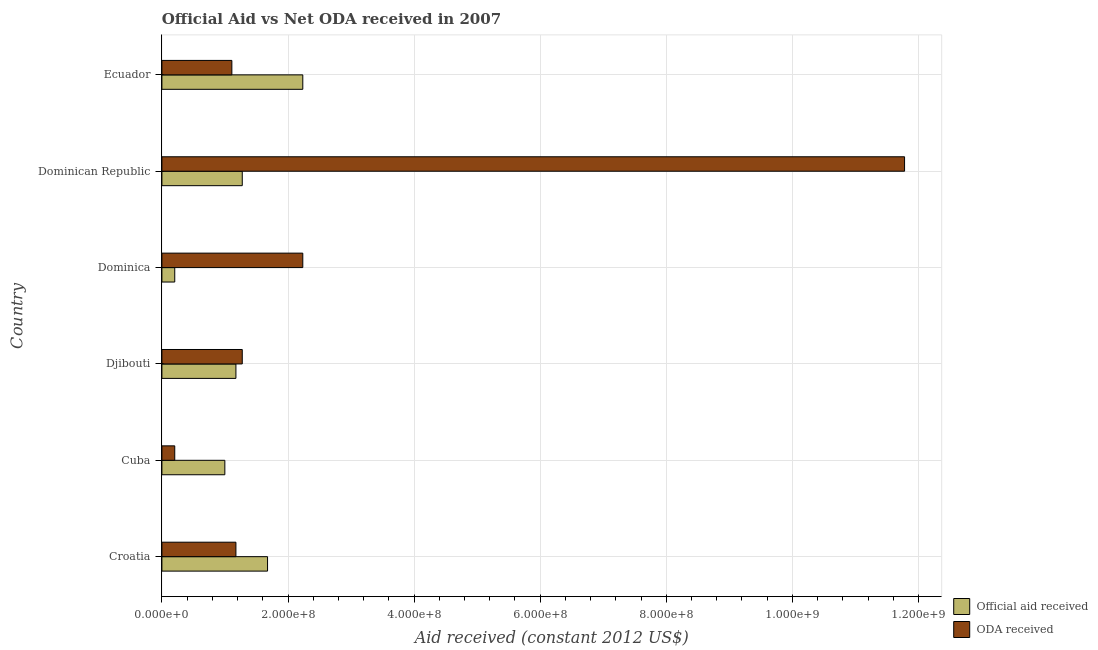What is the label of the 3rd group of bars from the top?
Offer a very short reply. Dominica. In how many cases, is the number of bars for a given country not equal to the number of legend labels?
Make the answer very short. 0. What is the oda received in Ecuador?
Your answer should be very brief. 1.11e+08. Across all countries, what is the maximum official aid received?
Make the answer very short. 2.23e+08. Across all countries, what is the minimum official aid received?
Ensure brevity in your answer.  2.04e+07. In which country was the oda received maximum?
Give a very brief answer. Dominican Republic. In which country was the oda received minimum?
Offer a terse response. Cuba. What is the total oda received in the graph?
Make the answer very short. 1.78e+09. What is the difference between the official aid received in Croatia and that in Ecuador?
Provide a short and direct response. -5.59e+07. What is the difference between the oda received in Croatia and the official aid received in Dominica?
Your answer should be very brief. 9.70e+07. What is the average official aid received per country?
Offer a terse response. 1.26e+08. What is the difference between the oda received and official aid received in Dominica?
Your response must be concise. 2.03e+08. What is the ratio of the official aid received in Djibouti to that in Ecuador?
Offer a very short reply. 0.53. What is the difference between the highest and the second highest oda received?
Your answer should be very brief. 9.54e+08. What is the difference between the highest and the lowest oda received?
Your response must be concise. 1.16e+09. What does the 2nd bar from the top in Djibouti represents?
Ensure brevity in your answer.  Official aid received. What does the 2nd bar from the bottom in Djibouti represents?
Offer a very short reply. ODA received. Are all the bars in the graph horizontal?
Give a very brief answer. Yes. What is the difference between two consecutive major ticks on the X-axis?
Your answer should be very brief. 2.00e+08. Does the graph contain grids?
Give a very brief answer. Yes. Where does the legend appear in the graph?
Ensure brevity in your answer.  Bottom right. What is the title of the graph?
Your response must be concise. Official Aid vs Net ODA received in 2007 . What is the label or title of the X-axis?
Your response must be concise. Aid received (constant 2012 US$). What is the Aid received (constant 2012 US$) in Official aid received in Croatia?
Offer a terse response. 1.68e+08. What is the Aid received (constant 2012 US$) in ODA received in Croatia?
Make the answer very short. 1.17e+08. What is the Aid received (constant 2012 US$) of Official aid received in Cuba?
Keep it short and to the point. 9.98e+07. What is the Aid received (constant 2012 US$) of ODA received in Cuba?
Provide a short and direct response. 2.04e+07. What is the Aid received (constant 2012 US$) in Official aid received in Djibouti?
Make the answer very short. 1.17e+08. What is the Aid received (constant 2012 US$) in ODA received in Djibouti?
Offer a very short reply. 1.27e+08. What is the Aid received (constant 2012 US$) in Official aid received in Dominica?
Give a very brief answer. 2.04e+07. What is the Aid received (constant 2012 US$) in ODA received in Dominica?
Keep it short and to the point. 2.23e+08. What is the Aid received (constant 2012 US$) in Official aid received in Dominican Republic?
Ensure brevity in your answer.  1.27e+08. What is the Aid received (constant 2012 US$) of ODA received in Dominican Republic?
Make the answer very short. 1.18e+09. What is the Aid received (constant 2012 US$) in Official aid received in Ecuador?
Your answer should be very brief. 2.23e+08. What is the Aid received (constant 2012 US$) in ODA received in Ecuador?
Provide a short and direct response. 1.11e+08. Across all countries, what is the maximum Aid received (constant 2012 US$) in Official aid received?
Give a very brief answer. 2.23e+08. Across all countries, what is the maximum Aid received (constant 2012 US$) of ODA received?
Give a very brief answer. 1.18e+09. Across all countries, what is the minimum Aid received (constant 2012 US$) in Official aid received?
Your answer should be compact. 2.04e+07. Across all countries, what is the minimum Aid received (constant 2012 US$) in ODA received?
Offer a terse response. 2.04e+07. What is the total Aid received (constant 2012 US$) of Official aid received in the graph?
Make the answer very short. 7.56e+08. What is the total Aid received (constant 2012 US$) in ODA received in the graph?
Your answer should be very brief. 1.78e+09. What is the difference between the Aid received (constant 2012 US$) of Official aid received in Croatia and that in Cuba?
Your response must be concise. 6.77e+07. What is the difference between the Aid received (constant 2012 US$) in ODA received in Croatia and that in Cuba?
Your response must be concise. 9.70e+07. What is the difference between the Aid received (constant 2012 US$) of Official aid received in Croatia and that in Djibouti?
Provide a short and direct response. 5.02e+07. What is the difference between the Aid received (constant 2012 US$) in ODA received in Croatia and that in Djibouti?
Your response must be concise. -1.01e+07. What is the difference between the Aid received (constant 2012 US$) of Official aid received in Croatia and that in Dominica?
Your answer should be very brief. 1.47e+08. What is the difference between the Aid received (constant 2012 US$) of ODA received in Croatia and that in Dominica?
Make the answer very short. -1.06e+08. What is the difference between the Aid received (constant 2012 US$) of Official aid received in Croatia and that in Dominican Republic?
Keep it short and to the point. 4.01e+07. What is the difference between the Aid received (constant 2012 US$) in ODA received in Croatia and that in Dominican Republic?
Your answer should be compact. -1.06e+09. What is the difference between the Aid received (constant 2012 US$) of Official aid received in Croatia and that in Ecuador?
Make the answer very short. -5.59e+07. What is the difference between the Aid received (constant 2012 US$) of ODA received in Croatia and that in Ecuador?
Keep it short and to the point. 6.43e+06. What is the difference between the Aid received (constant 2012 US$) in Official aid received in Cuba and that in Djibouti?
Keep it short and to the point. -1.76e+07. What is the difference between the Aid received (constant 2012 US$) in ODA received in Cuba and that in Djibouti?
Offer a terse response. -1.07e+08. What is the difference between the Aid received (constant 2012 US$) in Official aid received in Cuba and that in Dominica?
Provide a short and direct response. 7.94e+07. What is the difference between the Aid received (constant 2012 US$) of ODA received in Cuba and that in Dominica?
Your answer should be very brief. -2.03e+08. What is the difference between the Aid received (constant 2012 US$) in Official aid received in Cuba and that in Dominican Republic?
Provide a short and direct response. -2.76e+07. What is the difference between the Aid received (constant 2012 US$) of ODA received in Cuba and that in Dominican Republic?
Provide a short and direct response. -1.16e+09. What is the difference between the Aid received (constant 2012 US$) in Official aid received in Cuba and that in Ecuador?
Your answer should be compact. -1.24e+08. What is the difference between the Aid received (constant 2012 US$) of ODA received in Cuba and that in Ecuador?
Offer a very short reply. -9.06e+07. What is the difference between the Aid received (constant 2012 US$) of Official aid received in Djibouti and that in Dominica?
Offer a terse response. 9.70e+07. What is the difference between the Aid received (constant 2012 US$) in ODA received in Djibouti and that in Dominica?
Offer a terse response. -9.60e+07. What is the difference between the Aid received (constant 2012 US$) in Official aid received in Djibouti and that in Dominican Republic?
Your response must be concise. -1.01e+07. What is the difference between the Aid received (constant 2012 US$) in ODA received in Djibouti and that in Dominican Republic?
Your answer should be compact. -1.05e+09. What is the difference between the Aid received (constant 2012 US$) in Official aid received in Djibouti and that in Ecuador?
Offer a very short reply. -1.06e+08. What is the difference between the Aid received (constant 2012 US$) in ODA received in Djibouti and that in Ecuador?
Your response must be concise. 1.65e+07. What is the difference between the Aid received (constant 2012 US$) in Official aid received in Dominica and that in Dominican Republic?
Offer a very short reply. -1.07e+08. What is the difference between the Aid received (constant 2012 US$) in ODA received in Dominica and that in Dominican Republic?
Provide a succinct answer. -9.54e+08. What is the difference between the Aid received (constant 2012 US$) of Official aid received in Dominica and that in Ecuador?
Your answer should be compact. -2.03e+08. What is the difference between the Aid received (constant 2012 US$) in ODA received in Dominica and that in Ecuador?
Keep it short and to the point. 1.12e+08. What is the difference between the Aid received (constant 2012 US$) of Official aid received in Dominican Republic and that in Ecuador?
Make the answer very short. -9.60e+07. What is the difference between the Aid received (constant 2012 US$) of ODA received in Dominican Republic and that in Ecuador?
Offer a terse response. 1.07e+09. What is the difference between the Aid received (constant 2012 US$) in Official aid received in Croatia and the Aid received (constant 2012 US$) in ODA received in Cuba?
Your answer should be compact. 1.47e+08. What is the difference between the Aid received (constant 2012 US$) of Official aid received in Croatia and the Aid received (constant 2012 US$) of ODA received in Djibouti?
Your answer should be compact. 4.01e+07. What is the difference between the Aid received (constant 2012 US$) of Official aid received in Croatia and the Aid received (constant 2012 US$) of ODA received in Dominica?
Give a very brief answer. -5.59e+07. What is the difference between the Aid received (constant 2012 US$) in Official aid received in Croatia and the Aid received (constant 2012 US$) in ODA received in Dominican Republic?
Provide a succinct answer. -1.01e+09. What is the difference between the Aid received (constant 2012 US$) of Official aid received in Croatia and the Aid received (constant 2012 US$) of ODA received in Ecuador?
Make the answer very short. 5.66e+07. What is the difference between the Aid received (constant 2012 US$) in Official aid received in Cuba and the Aid received (constant 2012 US$) in ODA received in Djibouti?
Provide a succinct answer. -2.76e+07. What is the difference between the Aid received (constant 2012 US$) in Official aid received in Cuba and the Aid received (constant 2012 US$) in ODA received in Dominica?
Provide a succinct answer. -1.24e+08. What is the difference between the Aid received (constant 2012 US$) of Official aid received in Cuba and the Aid received (constant 2012 US$) of ODA received in Dominican Republic?
Your answer should be compact. -1.08e+09. What is the difference between the Aid received (constant 2012 US$) in Official aid received in Cuba and the Aid received (constant 2012 US$) in ODA received in Ecuador?
Your answer should be compact. -1.11e+07. What is the difference between the Aid received (constant 2012 US$) in Official aid received in Djibouti and the Aid received (constant 2012 US$) in ODA received in Dominica?
Ensure brevity in your answer.  -1.06e+08. What is the difference between the Aid received (constant 2012 US$) of Official aid received in Djibouti and the Aid received (constant 2012 US$) of ODA received in Dominican Republic?
Offer a very short reply. -1.06e+09. What is the difference between the Aid received (constant 2012 US$) in Official aid received in Djibouti and the Aid received (constant 2012 US$) in ODA received in Ecuador?
Make the answer very short. 6.43e+06. What is the difference between the Aid received (constant 2012 US$) in Official aid received in Dominica and the Aid received (constant 2012 US$) in ODA received in Dominican Republic?
Give a very brief answer. -1.16e+09. What is the difference between the Aid received (constant 2012 US$) in Official aid received in Dominica and the Aid received (constant 2012 US$) in ODA received in Ecuador?
Make the answer very short. -9.06e+07. What is the difference between the Aid received (constant 2012 US$) of Official aid received in Dominican Republic and the Aid received (constant 2012 US$) of ODA received in Ecuador?
Your answer should be very brief. 1.65e+07. What is the average Aid received (constant 2012 US$) of Official aid received per country?
Provide a succinct answer. 1.26e+08. What is the average Aid received (constant 2012 US$) of ODA received per country?
Your answer should be compact. 2.96e+08. What is the difference between the Aid received (constant 2012 US$) of Official aid received and Aid received (constant 2012 US$) of ODA received in Croatia?
Your answer should be very brief. 5.02e+07. What is the difference between the Aid received (constant 2012 US$) of Official aid received and Aid received (constant 2012 US$) of ODA received in Cuba?
Your answer should be compact. 7.94e+07. What is the difference between the Aid received (constant 2012 US$) in Official aid received and Aid received (constant 2012 US$) in ODA received in Djibouti?
Provide a succinct answer. -1.01e+07. What is the difference between the Aid received (constant 2012 US$) in Official aid received and Aid received (constant 2012 US$) in ODA received in Dominica?
Ensure brevity in your answer.  -2.03e+08. What is the difference between the Aid received (constant 2012 US$) in Official aid received and Aid received (constant 2012 US$) in ODA received in Dominican Republic?
Your response must be concise. -1.05e+09. What is the difference between the Aid received (constant 2012 US$) in Official aid received and Aid received (constant 2012 US$) in ODA received in Ecuador?
Your answer should be very brief. 1.12e+08. What is the ratio of the Aid received (constant 2012 US$) of Official aid received in Croatia to that in Cuba?
Provide a succinct answer. 1.68. What is the ratio of the Aid received (constant 2012 US$) in ODA received in Croatia to that in Cuba?
Ensure brevity in your answer.  5.76. What is the ratio of the Aid received (constant 2012 US$) of Official aid received in Croatia to that in Djibouti?
Provide a succinct answer. 1.43. What is the ratio of the Aid received (constant 2012 US$) in ODA received in Croatia to that in Djibouti?
Offer a very short reply. 0.92. What is the ratio of the Aid received (constant 2012 US$) in Official aid received in Croatia to that in Dominica?
Your answer should be compact. 8.22. What is the ratio of the Aid received (constant 2012 US$) in ODA received in Croatia to that in Dominica?
Give a very brief answer. 0.53. What is the ratio of the Aid received (constant 2012 US$) in Official aid received in Croatia to that in Dominican Republic?
Offer a terse response. 1.31. What is the ratio of the Aid received (constant 2012 US$) of ODA received in Croatia to that in Dominican Republic?
Keep it short and to the point. 0.1. What is the ratio of the Aid received (constant 2012 US$) of Official aid received in Croatia to that in Ecuador?
Provide a short and direct response. 0.75. What is the ratio of the Aid received (constant 2012 US$) in ODA received in Croatia to that in Ecuador?
Offer a very short reply. 1.06. What is the ratio of the Aid received (constant 2012 US$) of Official aid received in Cuba to that in Djibouti?
Keep it short and to the point. 0.85. What is the ratio of the Aid received (constant 2012 US$) of ODA received in Cuba to that in Djibouti?
Make the answer very short. 0.16. What is the ratio of the Aid received (constant 2012 US$) in Official aid received in Cuba to that in Dominica?
Provide a succinct answer. 4.9. What is the ratio of the Aid received (constant 2012 US$) of ODA received in Cuba to that in Dominica?
Keep it short and to the point. 0.09. What is the ratio of the Aid received (constant 2012 US$) in Official aid received in Cuba to that in Dominican Republic?
Ensure brevity in your answer.  0.78. What is the ratio of the Aid received (constant 2012 US$) of ODA received in Cuba to that in Dominican Republic?
Keep it short and to the point. 0.02. What is the ratio of the Aid received (constant 2012 US$) of Official aid received in Cuba to that in Ecuador?
Make the answer very short. 0.45. What is the ratio of the Aid received (constant 2012 US$) in ODA received in Cuba to that in Ecuador?
Give a very brief answer. 0.18. What is the ratio of the Aid received (constant 2012 US$) in Official aid received in Djibouti to that in Dominica?
Offer a terse response. 5.76. What is the ratio of the Aid received (constant 2012 US$) of ODA received in Djibouti to that in Dominica?
Offer a very short reply. 0.57. What is the ratio of the Aid received (constant 2012 US$) of Official aid received in Djibouti to that in Dominican Republic?
Offer a very short reply. 0.92. What is the ratio of the Aid received (constant 2012 US$) in ODA received in Djibouti to that in Dominican Republic?
Make the answer very short. 0.11. What is the ratio of the Aid received (constant 2012 US$) of Official aid received in Djibouti to that in Ecuador?
Keep it short and to the point. 0.53. What is the ratio of the Aid received (constant 2012 US$) in ODA received in Djibouti to that in Ecuador?
Make the answer very short. 1.15. What is the ratio of the Aid received (constant 2012 US$) in Official aid received in Dominica to that in Dominican Republic?
Provide a succinct answer. 0.16. What is the ratio of the Aid received (constant 2012 US$) of ODA received in Dominica to that in Dominican Republic?
Provide a short and direct response. 0.19. What is the ratio of the Aid received (constant 2012 US$) in Official aid received in Dominica to that in Ecuador?
Give a very brief answer. 0.09. What is the ratio of the Aid received (constant 2012 US$) of ODA received in Dominica to that in Ecuador?
Your answer should be very brief. 2.01. What is the ratio of the Aid received (constant 2012 US$) in Official aid received in Dominican Republic to that in Ecuador?
Make the answer very short. 0.57. What is the ratio of the Aid received (constant 2012 US$) of ODA received in Dominican Republic to that in Ecuador?
Ensure brevity in your answer.  10.62. What is the difference between the highest and the second highest Aid received (constant 2012 US$) of Official aid received?
Give a very brief answer. 5.59e+07. What is the difference between the highest and the second highest Aid received (constant 2012 US$) of ODA received?
Give a very brief answer. 9.54e+08. What is the difference between the highest and the lowest Aid received (constant 2012 US$) in Official aid received?
Make the answer very short. 2.03e+08. What is the difference between the highest and the lowest Aid received (constant 2012 US$) in ODA received?
Offer a very short reply. 1.16e+09. 